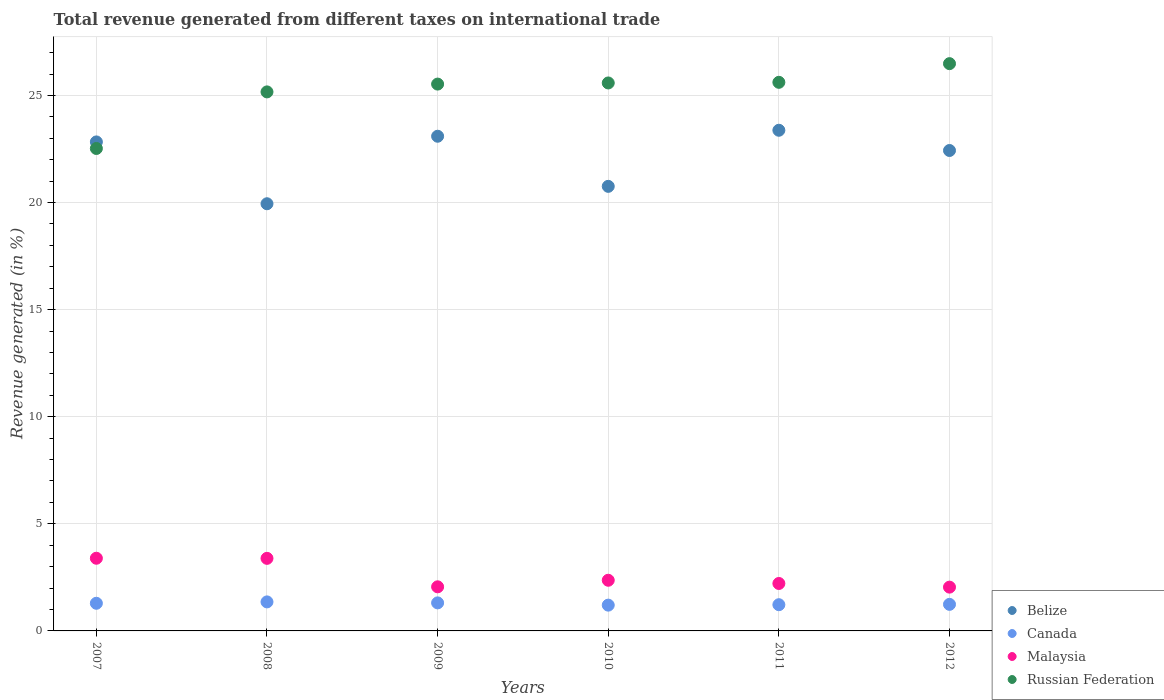How many different coloured dotlines are there?
Keep it short and to the point. 4. What is the total revenue generated in Malaysia in 2008?
Your answer should be compact. 3.39. Across all years, what is the maximum total revenue generated in Belize?
Your answer should be compact. 23.37. Across all years, what is the minimum total revenue generated in Malaysia?
Your response must be concise. 2.04. In which year was the total revenue generated in Malaysia maximum?
Provide a short and direct response. 2007. In which year was the total revenue generated in Russian Federation minimum?
Your response must be concise. 2007. What is the total total revenue generated in Belize in the graph?
Keep it short and to the point. 132.43. What is the difference between the total revenue generated in Russian Federation in 2007 and that in 2008?
Your response must be concise. -2.64. What is the difference between the total revenue generated in Russian Federation in 2010 and the total revenue generated in Malaysia in 2007?
Offer a terse response. 22.19. What is the average total revenue generated in Malaysia per year?
Ensure brevity in your answer.  2.58. In the year 2007, what is the difference between the total revenue generated in Canada and total revenue generated in Russian Federation?
Provide a succinct answer. -21.23. What is the ratio of the total revenue generated in Malaysia in 2009 to that in 2010?
Provide a short and direct response. 0.87. Is the total revenue generated in Malaysia in 2008 less than that in 2010?
Your response must be concise. No. What is the difference between the highest and the second highest total revenue generated in Canada?
Make the answer very short. 0.05. What is the difference between the highest and the lowest total revenue generated in Malaysia?
Offer a very short reply. 1.35. In how many years, is the total revenue generated in Canada greater than the average total revenue generated in Canada taken over all years?
Provide a succinct answer. 3. Is the sum of the total revenue generated in Belize in 2010 and 2012 greater than the maximum total revenue generated in Russian Federation across all years?
Provide a succinct answer. Yes. Is it the case that in every year, the sum of the total revenue generated in Belize and total revenue generated in Malaysia  is greater than the sum of total revenue generated in Russian Federation and total revenue generated in Canada?
Your answer should be compact. No. Does the total revenue generated in Canada monotonically increase over the years?
Your answer should be very brief. No. What is the difference between two consecutive major ticks on the Y-axis?
Provide a short and direct response. 5. Does the graph contain any zero values?
Give a very brief answer. No. What is the title of the graph?
Your answer should be very brief. Total revenue generated from different taxes on international trade. What is the label or title of the Y-axis?
Make the answer very short. Revenue generated (in %). What is the Revenue generated (in %) in Belize in 2007?
Keep it short and to the point. 22.83. What is the Revenue generated (in %) of Canada in 2007?
Offer a very short reply. 1.29. What is the Revenue generated (in %) in Malaysia in 2007?
Make the answer very short. 3.39. What is the Revenue generated (in %) of Russian Federation in 2007?
Ensure brevity in your answer.  22.52. What is the Revenue generated (in %) of Belize in 2008?
Keep it short and to the point. 19.94. What is the Revenue generated (in %) of Canada in 2008?
Keep it short and to the point. 1.36. What is the Revenue generated (in %) of Malaysia in 2008?
Offer a very short reply. 3.39. What is the Revenue generated (in %) in Russian Federation in 2008?
Keep it short and to the point. 25.17. What is the Revenue generated (in %) of Belize in 2009?
Give a very brief answer. 23.1. What is the Revenue generated (in %) of Canada in 2009?
Your answer should be very brief. 1.31. What is the Revenue generated (in %) of Malaysia in 2009?
Your answer should be very brief. 2.06. What is the Revenue generated (in %) in Russian Federation in 2009?
Give a very brief answer. 25.53. What is the Revenue generated (in %) in Belize in 2010?
Offer a terse response. 20.76. What is the Revenue generated (in %) of Canada in 2010?
Give a very brief answer. 1.2. What is the Revenue generated (in %) of Malaysia in 2010?
Offer a very short reply. 2.37. What is the Revenue generated (in %) of Russian Federation in 2010?
Make the answer very short. 25.58. What is the Revenue generated (in %) of Belize in 2011?
Give a very brief answer. 23.37. What is the Revenue generated (in %) in Canada in 2011?
Make the answer very short. 1.22. What is the Revenue generated (in %) in Malaysia in 2011?
Offer a very short reply. 2.21. What is the Revenue generated (in %) in Russian Federation in 2011?
Make the answer very short. 25.61. What is the Revenue generated (in %) in Belize in 2012?
Give a very brief answer. 22.43. What is the Revenue generated (in %) in Canada in 2012?
Offer a terse response. 1.24. What is the Revenue generated (in %) in Malaysia in 2012?
Your response must be concise. 2.04. What is the Revenue generated (in %) of Russian Federation in 2012?
Provide a succinct answer. 26.49. Across all years, what is the maximum Revenue generated (in %) of Belize?
Make the answer very short. 23.37. Across all years, what is the maximum Revenue generated (in %) in Canada?
Provide a short and direct response. 1.36. Across all years, what is the maximum Revenue generated (in %) in Malaysia?
Your answer should be very brief. 3.39. Across all years, what is the maximum Revenue generated (in %) of Russian Federation?
Offer a terse response. 26.49. Across all years, what is the minimum Revenue generated (in %) of Belize?
Give a very brief answer. 19.94. Across all years, what is the minimum Revenue generated (in %) of Canada?
Provide a succinct answer. 1.2. Across all years, what is the minimum Revenue generated (in %) of Malaysia?
Give a very brief answer. 2.04. Across all years, what is the minimum Revenue generated (in %) of Russian Federation?
Your response must be concise. 22.52. What is the total Revenue generated (in %) of Belize in the graph?
Provide a short and direct response. 132.43. What is the total Revenue generated (in %) in Canada in the graph?
Keep it short and to the point. 7.62. What is the total Revenue generated (in %) of Malaysia in the graph?
Give a very brief answer. 15.46. What is the total Revenue generated (in %) in Russian Federation in the graph?
Make the answer very short. 150.9. What is the difference between the Revenue generated (in %) in Belize in 2007 and that in 2008?
Your answer should be compact. 2.89. What is the difference between the Revenue generated (in %) of Canada in 2007 and that in 2008?
Provide a succinct answer. -0.06. What is the difference between the Revenue generated (in %) in Malaysia in 2007 and that in 2008?
Provide a short and direct response. 0.01. What is the difference between the Revenue generated (in %) of Russian Federation in 2007 and that in 2008?
Offer a terse response. -2.64. What is the difference between the Revenue generated (in %) in Belize in 2007 and that in 2009?
Make the answer very short. -0.27. What is the difference between the Revenue generated (in %) of Canada in 2007 and that in 2009?
Provide a succinct answer. -0.02. What is the difference between the Revenue generated (in %) in Malaysia in 2007 and that in 2009?
Provide a succinct answer. 1.33. What is the difference between the Revenue generated (in %) of Russian Federation in 2007 and that in 2009?
Offer a very short reply. -3.01. What is the difference between the Revenue generated (in %) in Belize in 2007 and that in 2010?
Your response must be concise. 2.07. What is the difference between the Revenue generated (in %) in Canada in 2007 and that in 2010?
Ensure brevity in your answer.  0.09. What is the difference between the Revenue generated (in %) in Malaysia in 2007 and that in 2010?
Keep it short and to the point. 1.03. What is the difference between the Revenue generated (in %) of Russian Federation in 2007 and that in 2010?
Your response must be concise. -3.06. What is the difference between the Revenue generated (in %) of Belize in 2007 and that in 2011?
Make the answer very short. -0.54. What is the difference between the Revenue generated (in %) of Canada in 2007 and that in 2011?
Make the answer very short. 0.07. What is the difference between the Revenue generated (in %) of Malaysia in 2007 and that in 2011?
Make the answer very short. 1.18. What is the difference between the Revenue generated (in %) of Russian Federation in 2007 and that in 2011?
Make the answer very short. -3.09. What is the difference between the Revenue generated (in %) of Belize in 2007 and that in 2012?
Provide a short and direct response. 0.4. What is the difference between the Revenue generated (in %) of Canada in 2007 and that in 2012?
Your answer should be very brief. 0.05. What is the difference between the Revenue generated (in %) of Malaysia in 2007 and that in 2012?
Make the answer very short. 1.35. What is the difference between the Revenue generated (in %) in Russian Federation in 2007 and that in 2012?
Offer a very short reply. -3.96. What is the difference between the Revenue generated (in %) in Belize in 2008 and that in 2009?
Your response must be concise. -3.15. What is the difference between the Revenue generated (in %) of Canada in 2008 and that in 2009?
Give a very brief answer. 0.05. What is the difference between the Revenue generated (in %) of Malaysia in 2008 and that in 2009?
Provide a succinct answer. 1.33. What is the difference between the Revenue generated (in %) in Russian Federation in 2008 and that in 2009?
Ensure brevity in your answer.  -0.36. What is the difference between the Revenue generated (in %) of Belize in 2008 and that in 2010?
Your answer should be very brief. -0.81. What is the difference between the Revenue generated (in %) in Canada in 2008 and that in 2010?
Your answer should be very brief. 0.15. What is the difference between the Revenue generated (in %) of Malaysia in 2008 and that in 2010?
Give a very brief answer. 1.02. What is the difference between the Revenue generated (in %) in Russian Federation in 2008 and that in 2010?
Provide a short and direct response. -0.42. What is the difference between the Revenue generated (in %) of Belize in 2008 and that in 2011?
Make the answer very short. -3.43. What is the difference between the Revenue generated (in %) of Canada in 2008 and that in 2011?
Make the answer very short. 0.13. What is the difference between the Revenue generated (in %) of Malaysia in 2008 and that in 2011?
Offer a terse response. 1.17. What is the difference between the Revenue generated (in %) in Russian Federation in 2008 and that in 2011?
Provide a succinct answer. -0.45. What is the difference between the Revenue generated (in %) of Belize in 2008 and that in 2012?
Your response must be concise. -2.49. What is the difference between the Revenue generated (in %) of Canada in 2008 and that in 2012?
Your response must be concise. 0.12. What is the difference between the Revenue generated (in %) in Malaysia in 2008 and that in 2012?
Provide a succinct answer. 1.34. What is the difference between the Revenue generated (in %) in Russian Federation in 2008 and that in 2012?
Keep it short and to the point. -1.32. What is the difference between the Revenue generated (in %) of Belize in 2009 and that in 2010?
Offer a terse response. 2.34. What is the difference between the Revenue generated (in %) in Canada in 2009 and that in 2010?
Offer a terse response. 0.11. What is the difference between the Revenue generated (in %) of Malaysia in 2009 and that in 2010?
Your answer should be compact. -0.31. What is the difference between the Revenue generated (in %) of Russian Federation in 2009 and that in 2010?
Offer a terse response. -0.05. What is the difference between the Revenue generated (in %) of Belize in 2009 and that in 2011?
Your answer should be compact. -0.28. What is the difference between the Revenue generated (in %) of Canada in 2009 and that in 2011?
Give a very brief answer. 0.09. What is the difference between the Revenue generated (in %) of Malaysia in 2009 and that in 2011?
Give a very brief answer. -0.16. What is the difference between the Revenue generated (in %) of Russian Federation in 2009 and that in 2011?
Your answer should be very brief. -0.08. What is the difference between the Revenue generated (in %) of Belize in 2009 and that in 2012?
Ensure brevity in your answer.  0.67. What is the difference between the Revenue generated (in %) in Canada in 2009 and that in 2012?
Ensure brevity in your answer.  0.07. What is the difference between the Revenue generated (in %) in Malaysia in 2009 and that in 2012?
Give a very brief answer. 0.01. What is the difference between the Revenue generated (in %) of Russian Federation in 2009 and that in 2012?
Make the answer very short. -0.95. What is the difference between the Revenue generated (in %) of Belize in 2010 and that in 2011?
Keep it short and to the point. -2.62. What is the difference between the Revenue generated (in %) of Canada in 2010 and that in 2011?
Keep it short and to the point. -0.02. What is the difference between the Revenue generated (in %) in Malaysia in 2010 and that in 2011?
Offer a terse response. 0.15. What is the difference between the Revenue generated (in %) in Russian Federation in 2010 and that in 2011?
Keep it short and to the point. -0.03. What is the difference between the Revenue generated (in %) in Belize in 2010 and that in 2012?
Your answer should be very brief. -1.67. What is the difference between the Revenue generated (in %) in Canada in 2010 and that in 2012?
Give a very brief answer. -0.04. What is the difference between the Revenue generated (in %) of Malaysia in 2010 and that in 2012?
Provide a short and direct response. 0.32. What is the difference between the Revenue generated (in %) of Russian Federation in 2010 and that in 2012?
Give a very brief answer. -0.9. What is the difference between the Revenue generated (in %) of Belize in 2011 and that in 2012?
Your answer should be very brief. 0.94. What is the difference between the Revenue generated (in %) in Canada in 2011 and that in 2012?
Make the answer very short. -0.02. What is the difference between the Revenue generated (in %) in Malaysia in 2011 and that in 2012?
Give a very brief answer. 0.17. What is the difference between the Revenue generated (in %) of Russian Federation in 2011 and that in 2012?
Provide a succinct answer. -0.87. What is the difference between the Revenue generated (in %) in Belize in 2007 and the Revenue generated (in %) in Canada in 2008?
Provide a succinct answer. 21.48. What is the difference between the Revenue generated (in %) in Belize in 2007 and the Revenue generated (in %) in Malaysia in 2008?
Your answer should be compact. 19.44. What is the difference between the Revenue generated (in %) in Belize in 2007 and the Revenue generated (in %) in Russian Federation in 2008?
Make the answer very short. -2.34. What is the difference between the Revenue generated (in %) in Canada in 2007 and the Revenue generated (in %) in Malaysia in 2008?
Keep it short and to the point. -2.1. What is the difference between the Revenue generated (in %) of Canada in 2007 and the Revenue generated (in %) of Russian Federation in 2008?
Provide a short and direct response. -23.88. What is the difference between the Revenue generated (in %) in Malaysia in 2007 and the Revenue generated (in %) in Russian Federation in 2008?
Your answer should be very brief. -21.77. What is the difference between the Revenue generated (in %) in Belize in 2007 and the Revenue generated (in %) in Canada in 2009?
Provide a short and direct response. 21.52. What is the difference between the Revenue generated (in %) of Belize in 2007 and the Revenue generated (in %) of Malaysia in 2009?
Provide a succinct answer. 20.77. What is the difference between the Revenue generated (in %) of Canada in 2007 and the Revenue generated (in %) of Malaysia in 2009?
Offer a very short reply. -0.77. What is the difference between the Revenue generated (in %) of Canada in 2007 and the Revenue generated (in %) of Russian Federation in 2009?
Provide a succinct answer. -24.24. What is the difference between the Revenue generated (in %) in Malaysia in 2007 and the Revenue generated (in %) in Russian Federation in 2009?
Keep it short and to the point. -22.14. What is the difference between the Revenue generated (in %) in Belize in 2007 and the Revenue generated (in %) in Canada in 2010?
Your answer should be compact. 21.63. What is the difference between the Revenue generated (in %) of Belize in 2007 and the Revenue generated (in %) of Malaysia in 2010?
Give a very brief answer. 20.47. What is the difference between the Revenue generated (in %) of Belize in 2007 and the Revenue generated (in %) of Russian Federation in 2010?
Provide a succinct answer. -2.75. What is the difference between the Revenue generated (in %) of Canada in 2007 and the Revenue generated (in %) of Malaysia in 2010?
Make the answer very short. -1.07. What is the difference between the Revenue generated (in %) of Canada in 2007 and the Revenue generated (in %) of Russian Federation in 2010?
Provide a short and direct response. -24.29. What is the difference between the Revenue generated (in %) of Malaysia in 2007 and the Revenue generated (in %) of Russian Federation in 2010?
Offer a terse response. -22.19. What is the difference between the Revenue generated (in %) of Belize in 2007 and the Revenue generated (in %) of Canada in 2011?
Give a very brief answer. 21.61. What is the difference between the Revenue generated (in %) of Belize in 2007 and the Revenue generated (in %) of Malaysia in 2011?
Provide a short and direct response. 20.62. What is the difference between the Revenue generated (in %) in Belize in 2007 and the Revenue generated (in %) in Russian Federation in 2011?
Offer a very short reply. -2.78. What is the difference between the Revenue generated (in %) of Canada in 2007 and the Revenue generated (in %) of Malaysia in 2011?
Your answer should be very brief. -0.92. What is the difference between the Revenue generated (in %) of Canada in 2007 and the Revenue generated (in %) of Russian Federation in 2011?
Make the answer very short. -24.32. What is the difference between the Revenue generated (in %) of Malaysia in 2007 and the Revenue generated (in %) of Russian Federation in 2011?
Your answer should be compact. -22.22. What is the difference between the Revenue generated (in %) in Belize in 2007 and the Revenue generated (in %) in Canada in 2012?
Offer a terse response. 21.59. What is the difference between the Revenue generated (in %) in Belize in 2007 and the Revenue generated (in %) in Malaysia in 2012?
Offer a terse response. 20.79. What is the difference between the Revenue generated (in %) of Belize in 2007 and the Revenue generated (in %) of Russian Federation in 2012?
Ensure brevity in your answer.  -3.65. What is the difference between the Revenue generated (in %) in Canada in 2007 and the Revenue generated (in %) in Malaysia in 2012?
Provide a short and direct response. -0.75. What is the difference between the Revenue generated (in %) of Canada in 2007 and the Revenue generated (in %) of Russian Federation in 2012?
Make the answer very short. -25.19. What is the difference between the Revenue generated (in %) of Malaysia in 2007 and the Revenue generated (in %) of Russian Federation in 2012?
Give a very brief answer. -23.09. What is the difference between the Revenue generated (in %) of Belize in 2008 and the Revenue generated (in %) of Canada in 2009?
Offer a terse response. 18.63. What is the difference between the Revenue generated (in %) in Belize in 2008 and the Revenue generated (in %) in Malaysia in 2009?
Your response must be concise. 17.89. What is the difference between the Revenue generated (in %) of Belize in 2008 and the Revenue generated (in %) of Russian Federation in 2009?
Offer a very short reply. -5.59. What is the difference between the Revenue generated (in %) of Canada in 2008 and the Revenue generated (in %) of Malaysia in 2009?
Ensure brevity in your answer.  -0.7. What is the difference between the Revenue generated (in %) of Canada in 2008 and the Revenue generated (in %) of Russian Federation in 2009?
Your response must be concise. -24.18. What is the difference between the Revenue generated (in %) of Malaysia in 2008 and the Revenue generated (in %) of Russian Federation in 2009?
Your response must be concise. -22.14. What is the difference between the Revenue generated (in %) of Belize in 2008 and the Revenue generated (in %) of Canada in 2010?
Your answer should be compact. 18.74. What is the difference between the Revenue generated (in %) in Belize in 2008 and the Revenue generated (in %) in Malaysia in 2010?
Make the answer very short. 17.58. What is the difference between the Revenue generated (in %) in Belize in 2008 and the Revenue generated (in %) in Russian Federation in 2010?
Keep it short and to the point. -5.64. What is the difference between the Revenue generated (in %) in Canada in 2008 and the Revenue generated (in %) in Malaysia in 2010?
Provide a short and direct response. -1.01. What is the difference between the Revenue generated (in %) of Canada in 2008 and the Revenue generated (in %) of Russian Federation in 2010?
Provide a short and direct response. -24.23. What is the difference between the Revenue generated (in %) of Malaysia in 2008 and the Revenue generated (in %) of Russian Federation in 2010?
Give a very brief answer. -22.2. What is the difference between the Revenue generated (in %) in Belize in 2008 and the Revenue generated (in %) in Canada in 2011?
Make the answer very short. 18.72. What is the difference between the Revenue generated (in %) of Belize in 2008 and the Revenue generated (in %) of Malaysia in 2011?
Give a very brief answer. 17.73. What is the difference between the Revenue generated (in %) in Belize in 2008 and the Revenue generated (in %) in Russian Federation in 2011?
Ensure brevity in your answer.  -5.67. What is the difference between the Revenue generated (in %) in Canada in 2008 and the Revenue generated (in %) in Malaysia in 2011?
Ensure brevity in your answer.  -0.86. What is the difference between the Revenue generated (in %) in Canada in 2008 and the Revenue generated (in %) in Russian Federation in 2011?
Your response must be concise. -24.26. What is the difference between the Revenue generated (in %) in Malaysia in 2008 and the Revenue generated (in %) in Russian Federation in 2011?
Your answer should be compact. -22.22. What is the difference between the Revenue generated (in %) in Belize in 2008 and the Revenue generated (in %) in Canada in 2012?
Provide a succinct answer. 18.7. What is the difference between the Revenue generated (in %) of Belize in 2008 and the Revenue generated (in %) of Malaysia in 2012?
Make the answer very short. 17.9. What is the difference between the Revenue generated (in %) of Belize in 2008 and the Revenue generated (in %) of Russian Federation in 2012?
Your response must be concise. -6.54. What is the difference between the Revenue generated (in %) of Canada in 2008 and the Revenue generated (in %) of Malaysia in 2012?
Keep it short and to the point. -0.69. What is the difference between the Revenue generated (in %) of Canada in 2008 and the Revenue generated (in %) of Russian Federation in 2012?
Offer a terse response. -25.13. What is the difference between the Revenue generated (in %) in Malaysia in 2008 and the Revenue generated (in %) in Russian Federation in 2012?
Your response must be concise. -23.1. What is the difference between the Revenue generated (in %) of Belize in 2009 and the Revenue generated (in %) of Canada in 2010?
Provide a short and direct response. 21.89. What is the difference between the Revenue generated (in %) of Belize in 2009 and the Revenue generated (in %) of Malaysia in 2010?
Offer a terse response. 20.73. What is the difference between the Revenue generated (in %) in Belize in 2009 and the Revenue generated (in %) in Russian Federation in 2010?
Provide a succinct answer. -2.49. What is the difference between the Revenue generated (in %) of Canada in 2009 and the Revenue generated (in %) of Malaysia in 2010?
Give a very brief answer. -1.06. What is the difference between the Revenue generated (in %) in Canada in 2009 and the Revenue generated (in %) in Russian Federation in 2010?
Make the answer very short. -24.27. What is the difference between the Revenue generated (in %) in Malaysia in 2009 and the Revenue generated (in %) in Russian Federation in 2010?
Make the answer very short. -23.52. What is the difference between the Revenue generated (in %) in Belize in 2009 and the Revenue generated (in %) in Canada in 2011?
Make the answer very short. 21.87. What is the difference between the Revenue generated (in %) in Belize in 2009 and the Revenue generated (in %) in Malaysia in 2011?
Make the answer very short. 20.88. What is the difference between the Revenue generated (in %) in Belize in 2009 and the Revenue generated (in %) in Russian Federation in 2011?
Your answer should be compact. -2.52. What is the difference between the Revenue generated (in %) of Canada in 2009 and the Revenue generated (in %) of Malaysia in 2011?
Offer a very short reply. -0.91. What is the difference between the Revenue generated (in %) of Canada in 2009 and the Revenue generated (in %) of Russian Federation in 2011?
Ensure brevity in your answer.  -24.3. What is the difference between the Revenue generated (in %) in Malaysia in 2009 and the Revenue generated (in %) in Russian Federation in 2011?
Provide a succinct answer. -23.55. What is the difference between the Revenue generated (in %) in Belize in 2009 and the Revenue generated (in %) in Canada in 2012?
Offer a very short reply. 21.86. What is the difference between the Revenue generated (in %) of Belize in 2009 and the Revenue generated (in %) of Malaysia in 2012?
Give a very brief answer. 21.05. What is the difference between the Revenue generated (in %) of Belize in 2009 and the Revenue generated (in %) of Russian Federation in 2012?
Your answer should be very brief. -3.39. What is the difference between the Revenue generated (in %) of Canada in 2009 and the Revenue generated (in %) of Malaysia in 2012?
Provide a succinct answer. -0.73. What is the difference between the Revenue generated (in %) of Canada in 2009 and the Revenue generated (in %) of Russian Federation in 2012?
Provide a short and direct response. -25.18. What is the difference between the Revenue generated (in %) in Malaysia in 2009 and the Revenue generated (in %) in Russian Federation in 2012?
Provide a short and direct response. -24.43. What is the difference between the Revenue generated (in %) of Belize in 2010 and the Revenue generated (in %) of Canada in 2011?
Ensure brevity in your answer.  19.53. What is the difference between the Revenue generated (in %) of Belize in 2010 and the Revenue generated (in %) of Malaysia in 2011?
Provide a short and direct response. 18.54. What is the difference between the Revenue generated (in %) in Belize in 2010 and the Revenue generated (in %) in Russian Federation in 2011?
Provide a short and direct response. -4.86. What is the difference between the Revenue generated (in %) of Canada in 2010 and the Revenue generated (in %) of Malaysia in 2011?
Keep it short and to the point. -1.01. What is the difference between the Revenue generated (in %) in Canada in 2010 and the Revenue generated (in %) in Russian Federation in 2011?
Your answer should be compact. -24.41. What is the difference between the Revenue generated (in %) in Malaysia in 2010 and the Revenue generated (in %) in Russian Federation in 2011?
Your response must be concise. -23.25. What is the difference between the Revenue generated (in %) of Belize in 2010 and the Revenue generated (in %) of Canada in 2012?
Keep it short and to the point. 19.52. What is the difference between the Revenue generated (in %) in Belize in 2010 and the Revenue generated (in %) in Malaysia in 2012?
Make the answer very short. 18.71. What is the difference between the Revenue generated (in %) of Belize in 2010 and the Revenue generated (in %) of Russian Federation in 2012?
Make the answer very short. -5.73. What is the difference between the Revenue generated (in %) in Canada in 2010 and the Revenue generated (in %) in Malaysia in 2012?
Offer a terse response. -0.84. What is the difference between the Revenue generated (in %) of Canada in 2010 and the Revenue generated (in %) of Russian Federation in 2012?
Your answer should be very brief. -25.28. What is the difference between the Revenue generated (in %) of Malaysia in 2010 and the Revenue generated (in %) of Russian Federation in 2012?
Make the answer very short. -24.12. What is the difference between the Revenue generated (in %) of Belize in 2011 and the Revenue generated (in %) of Canada in 2012?
Keep it short and to the point. 22.13. What is the difference between the Revenue generated (in %) in Belize in 2011 and the Revenue generated (in %) in Malaysia in 2012?
Ensure brevity in your answer.  21.33. What is the difference between the Revenue generated (in %) in Belize in 2011 and the Revenue generated (in %) in Russian Federation in 2012?
Provide a short and direct response. -3.11. What is the difference between the Revenue generated (in %) of Canada in 2011 and the Revenue generated (in %) of Malaysia in 2012?
Ensure brevity in your answer.  -0.82. What is the difference between the Revenue generated (in %) of Canada in 2011 and the Revenue generated (in %) of Russian Federation in 2012?
Your answer should be very brief. -25.26. What is the difference between the Revenue generated (in %) of Malaysia in 2011 and the Revenue generated (in %) of Russian Federation in 2012?
Make the answer very short. -24.27. What is the average Revenue generated (in %) in Belize per year?
Provide a succinct answer. 22.07. What is the average Revenue generated (in %) of Canada per year?
Your answer should be compact. 1.27. What is the average Revenue generated (in %) in Malaysia per year?
Ensure brevity in your answer.  2.58. What is the average Revenue generated (in %) in Russian Federation per year?
Ensure brevity in your answer.  25.15. In the year 2007, what is the difference between the Revenue generated (in %) of Belize and Revenue generated (in %) of Canada?
Provide a short and direct response. 21.54. In the year 2007, what is the difference between the Revenue generated (in %) in Belize and Revenue generated (in %) in Malaysia?
Give a very brief answer. 19.44. In the year 2007, what is the difference between the Revenue generated (in %) in Belize and Revenue generated (in %) in Russian Federation?
Keep it short and to the point. 0.31. In the year 2007, what is the difference between the Revenue generated (in %) in Canada and Revenue generated (in %) in Malaysia?
Ensure brevity in your answer.  -2.1. In the year 2007, what is the difference between the Revenue generated (in %) in Canada and Revenue generated (in %) in Russian Federation?
Your answer should be very brief. -21.23. In the year 2007, what is the difference between the Revenue generated (in %) in Malaysia and Revenue generated (in %) in Russian Federation?
Ensure brevity in your answer.  -19.13. In the year 2008, what is the difference between the Revenue generated (in %) in Belize and Revenue generated (in %) in Canada?
Keep it short and to the point. 18.59. In the year 2008, what is the difference between the Revenue generated (in %) of Belize and Revenue generated (in %) of Malaysia?
Offer a terse response. 16.56. In the year 2008, what is the difference between the Revenue generated (in %) of Belize and Revenue generated (in %) of Russian Federation?
Give a very brief answer. -5.22. In the year 2008, what is the difference between the Revenue generated (in %) of Canada and Revenue generated (in %) of Malaysia?
Your response must be concise. -2.03. In the year 2008, what is the difference between the Revenue generated (in %) of Canada and Revenue generated (in %) of Russian Federation?
Your answer should be compact. -23.81. In the year 2008, what is the difference between the Revenue generated (in %) in Malaysia and Revenue generated (in %) in Russian Federation?
Offer a terse response. -21.78. In the year 2009, what is the difference between the Revenue generated (in %) of Belize and Revenue generated (in %) of Canada?
Your answer should be compact. 21.79. In the year 2009, what is the difference between the Revenue generated (in %) in Belize and Revenue generated (in %) in Malaysia?
Make the answer very short. 21.04. In the year 2009, what is the difference between the Revenue generated (in %) of Belize and Revenue generated (in %) of Russian Federation?
Your answer should be compact. -2.43. In the year 2009, what is the difference between the Revenue generated (in %) in Canada and Revenue generated (in %) in Malaysia?
Your answer should be very brief. -0.75. In the year 2009, what is the difference between the Revenue generated (in %) in Canada and Revenue generated (in %) in Russian Federation?
Make the answer very short. -24.22. In the year 2009, what is the difference between the Revenue generated (in %) in Malaysia and Revenue generated (in %) in Russian Federation?
Keep it short and to the point. -23.47. In the year 2010, what is the difference between the Revenue generated (in %) of Belize and Revenue generated (in %) of Canada?
Offer a very short reply. 19.55. In the year 2010, what is the difference between the Revenue generated (in %) in Belize and Revenue generated (in %) in Malaysia?
Ensure brevity in your answer.  18.39. In the year 2010, what is the difference between the Revenue generated (in %) of Belize and Revenue generated (in %) of Russian Federation?
Your answer should be compact. -4.83. In the year 2010, what is the difference between the Revenue generated (in %) of Canada and Revenue generated (in %) of Malaysia?
Your answer should be compact. -1.16. In the year 2010, what is the difference between the Revenue generated (in %) of Canada and Revenue generated (in %) of Russian Federation?
Give a very brief answer. -24.38. In the year 2010, what is the difference between the Revenue generated (in %) of Malaysia and Revenue generated (in %) of Russian Federation?
Offer a very short reply. -23.22. In the year 2011, what is the difference between the Revenue generated (in %) in Belize and Revenue generated (in %) in Canada?
Keep it short and to the point. 22.15. In the year 2011, what is the difference between the Revenue generated (in %) of Belize and Revenue generated (in %) of Malaysia?
Your response must be concise. 21.16. In the year 2011, what is the difference between the Revenue generated (in %) of Belize and Revenue generated (in %) of Russian Federation?
Provide a succinct answer. -2.24. In the year 2011, what is the difference between the Revenue generated (in %) in Canada and Revenue generated (in %) in Malaysia?
Your response must be concise. -0.99. In the year 2011, what is the difference between the Revenue generated (in %) of Canada and Revenue generated (in %) of Russian Federation?
Your answer should be compact. -24.39. In the year 2011, what is the difference between the Revenue generated (in %) of Malaysia and Revenue generated (in %) of Russian Federation?
Make the answer very short. -23.4. In the year 2012, what is the difference between the Revenue generated (in %) in Belize and Revenue generated (in %) in Canada?
Your answer should be very brief. 21.19. In the year 2012, what is the difference between the Revenue generated (in %) of Belize and Revenue generated (in %) of Malaysia?
Keep it short and to the point. 20.39. In the year 2012, what is the difference between the Revenue generated (in %) of Belize and Revenue generated (in %) of Russian Federation?
Provide a succinct answer. -4.05. In the year 2012, what is the difference between the Revenue generated (in %) in Canada and Revenue generated (in %) in Malaysia?
Your answer should be very brief. -0.8. In the year 2012, what is the difference between the Revenue generated (in %) in Canada and Revenue generated (in %) in Russian Federation?
Make the answer very short. -25.25. In the year 2012, what is the difference between the Revenue generated (in %) in Malaysia and Revenue generated (in %) in Russian Federation?
Your response must be concise. -24.44. What is the ratio of the Revenue generated (in %) of Belize in 2007 to that in 2008?
Offer a terse response. 1.14. What is the ratio of the Revenue generated (in %) of Canada in 2007 to that in 2008?
Your answer should be compact. 0.95. What is the ratio of the Revenue generated (in %) of Malaysia in 2007 to that in 2008?
Offer a very short reply. 1. What is the ratio of the Revenue generated (in %) in Russian Federation in 2007 to that in 2008?
Make the answer very short. 0.9. What is the ratio of the Revenue generated (in %) of Canada in 2007 to that in 2009?
Provide a succinct answer. 0.99. What is the ratio of the Revenue generated (in %) in Malaysia in 2007 to that in 2009?
Offer a very short reply. 1.65. What is the ratio of the Revenue generated (in %) of Russian Federation in 2007 to that in 2009?
Offer a very short reply. 0.88. What is the ratio of the Revenue generated (in %) of Belize in 2007 to that in 2010?
Your answer should be compact. 1.1. What is the ratio of the Revenue generated (in %) in Canada in 2007 to that in 2010?
Make the answer very short. 1.07. What is the ratio of the Revenue generated (in %) in Malaysia in 2007 to that in 2010?
Keep it short and to the point. 1.43. What is the ratio of the Revenue generated (in %) in Russian Federation in 2007 to that in 2010?
Give a very brief answer. 0.88. What is the ratio of the Revenue generated (in %) of Belize in 2007 to that in 2011?
Provide a short and direct response. 0.98. What is the ratio of the Revenue generated (in %) of Canada in 2007 to that in 2011?
Your answer should be very brief. 1.05. What is the ratio of the Revenue generated (in %) of Malaysia in 2007 to that in 2011?
Offer a very short reply. 1.53. What is the ratio of the Revenue generated (in %) of Russian Federation in 2007 to that in 2011?
Your answer should be very brief. 0.88. What is the ratio of the Revenue generated (in %) of Belize in 2007 to that in 2012?
Your answer should be very brief. 1.02. What is the ratio of the Revenue generated (in %) in Canada in 2007 to that in 2012?
Ensure brevity in your answer.  1.04. What is the ratio of the Revenue generated (in %) of Malaysia in 2007 to that in 2012?
Ensure brevity in your answer.  1.66. What is the ratio of the Revenue generated (in %) of Russian Federation in 2007 to that in 2012?
Your answer should be compact. 0.85. What is the ratio of the Revenue generated (in %) of Belize in 2008 to that in 2009?
Give a very brief answer. 0.86. What is the ratio of the Revenue generated (in %) in Canada in 2008 to that in 2009?
Offer a very short reply. 1.03. What is the ratio of the Revenue generated (in %) of Malaysia in 2008 to that in 2009?
Provide a succinct answer. 1.65. What is the ratio of the Revenue generated (in %) of Russian Federation in 2008 to that in 2009?
Provide a short and direct response. 0.99. What is the ratio of the Revenue generated (in %) in Belize in 2008 to that in 2010?
Provide a short and direct response. 0.96. What is the ratio of the Revenue generated (in %) of Canada in 2008 to that in 2010?
Your answer should be compact. 1.13. What is the ratio of the Revenue generated (in %) in Malaysia in 2008 to that in 2010?
Provide a succinct answer. 1.43. What is the ratio of the Revenue generated (in %) in Russian Federation in 2008 to that in 2010?
Your response must be concise. 0.98. What is the ratio of the Revenue generated (in %) of Belize in 2008 to that in 2011?
Offer a terse response. 0.85. What is the ratio of the Revenue generated (in %) of Canada in 2008 to that in 2011?
Offer a terse response. 1.11. What is the ratio of the Revenue generated (in %) in Malaysia in 2008 to that in 2011?
Your answer should be very brief. 1.53. What is the ratio of the Revenue generated (in %) of Russian Federation in 2008 to that in 2011?
Keep it short and to the point. 0.98. What is the ratio of the Revenue generated (in %) in Belize in 2008 to that in 2012?
Your answer should be very brief. 0.89. What is the ratio of the Revenue generated (in %) in Canada in 2008 to that in 2012?
Offer a terse response. 1.09. What is the ratio of the Revenue generated (in %) in Malaysia in 2008 to that in 2012?
Give a very brief answer. 1.66. What is the ratio of the Revenue generated (in %) in Russian Federation in 2008 to that in 2012?
Offer a very short reply. 0.95. What is the ratio of the Revenue generated (in %) in Belize in 2009 to that in 2010?
Your response must be concise. 1.11. What is the ratio of the Revenue generated (in %) in Canada in 2009 to that in 2010?
Your answer should be compact. 1.09. What is the ratio of the Revenue generated (in %) in Malaysia in 2009 to that in 2010?
Your response must be concise. 0.87. What is the ratio of the Revenue generated (in %) in Belize in 2009 to that in 2011?
Your response must be concise. 0.99. What is the ratio of the Revenue generated (in %) of Canada in 2009 to that in 2011?
Make the answer very short. 1.07. What is the ratio of the Revenue generated (in %) in Malaysia in 2009 to that in 2011?
Ensure brevity in your answer.  0.93. What is the ratio of the Revenue generated (in %) of Russian Federation in 2009 to that in 2011?
Provide a succinct answer. 1. What is the ratio of the Revenue generated (in %) in Belize in 2009 to that in 2012?
Provide a succinct answer. 1.03. What is the ratio of the Revenue generated (in %) of Canada in 2009 to that in 2012?
Provide a succinct answer. 1.06. What is the ratio of the Revenue generated (in %) of Malaysia in 2009 to that in 2012?
Ensure brevity in your answer.  1.01. What is the ratio of the Revenue generated (in %) in Russian Federation in 2009 to that in 2012?
Make the answer very short. 0.96. What is the ratio of the Revenue generated (in %) in Belize in 2010 to that in 2011?
Your answer should be compact. 0.89. What is the ratio of the Revenue generated (in %) in Canada in 2010 to that in 2011?
Offer a very short reply. 0.98. What is the ratio of the Revenue generated (in %) of Malaysia in 2010 to that in 2011?
Ensure brevity in your answer.  1.07. What is the ratio of the Revenue generated (in %) in Belize in 2010 to that in 2012?
Make the answer very short. 0.93. What is the ratio of the Revenue generated (in %) of Canada in 2010 to that in 2012?
Offer a very short reply. 0.97. What is the ratio of the Revenue generated (in %) in Malaysia in 2010 to that in 2012?
Offer a terse response. 1.16. What is the ratio of the Revenue generated (in %) of Russian Federation in 2010 to that in 2012?
Provide a short and direct response. 0.97. What is the ratio of the Revenue generated (in %) in Belize in 2011 to that in 2012?
Ensure brevity in your answer.  1.04. What is the ratio of the Revenue generated (in %) in Canada in 2011 to that in 2012?
Offer a very short reply. 0.99. What is the ratio of the Revenue generated (in %) of Malaysia in 2011 to that in 2012?
Provide a short and direct response. 1.08. What is the ratio of the Revenue generated (in %) of Russian Federation in 2011 to that in 2012?
Your answer should be very brief. 0.97. What is the difference between the highest and the second highest Revenue generated (in %) in Belize?
Your response must be concise. 0.28. What is the difference between the highest and the second highest Revenue generated (in %) in Canada?
Make the answer very short. 0.05. What is the difference between the highest and the second highest Revenue generated (in %) in Malaysia?
Offer a very short reply. 0.01. What is the difference between the highest and the second highest Revenue generated (in %) in Russian Federation?
Your response must be concise. 0.87. What is the difference between the highest and the lowest Revenue generated (in %) in Belize?
Your answer should be very brief. 3.43. What is the difference between the highest and the lowest Revenue generated (in %) in Canada?
Your answer should be very brief. 0.15. What is the difference between the highest and the lowest Revenue generated (in %) in Malaysia?
Provide a succinct answer. 1.35. What is the difference between the highest and the lowest Revenue generated (in %) of Russian Federation?
Give a very brief answer. 3.96. 